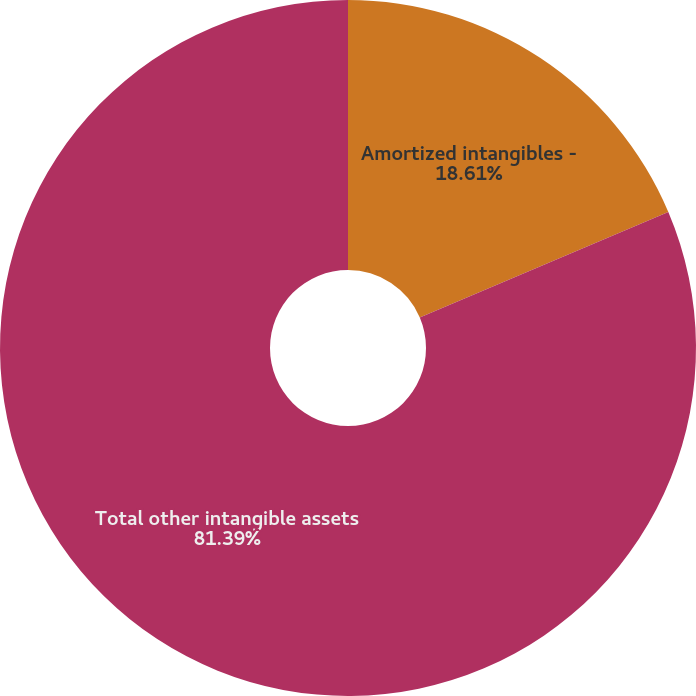<chart> <loc_0><loc_0><loc_500><loc_500><pie_chart><fcel>Amortized intangibles -<fcel>Total other intangible assets<nl><fcel>18.61%<fcel>81.39%<nl></chart> 